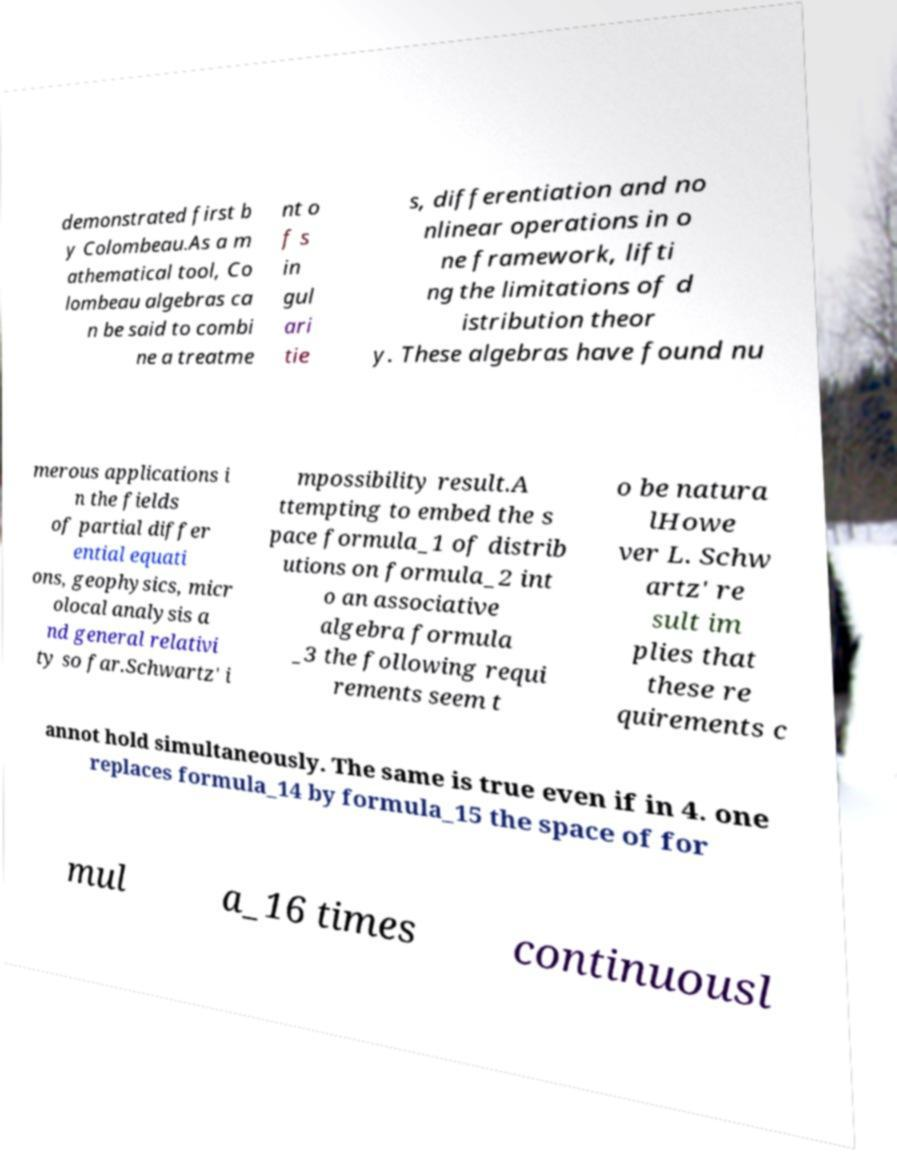There's text embedded in this image that I need extracted. Can you transcribe it verbatim? demonstrated first b y Colombeau.As a m athematical tool, Co lombeau algebras ca n be said to combi ne a treatme nt o f s in gul ari tie s, differentiation and no nlinear operations in o ne framework, lifti ng the limitations of d istribution theor y. These algebras have found nu merous applications i n the fields of partial differ ential equati ons, geophysics, micr olocal analysis a nd general relativi ty so far.Schwartz' i mpossibility result.A ttempting to embed the s pace formula_1 of distrib utions on formula_2 int o an associative algebra formula _3 the following requi rements seem t o be natura lHowe ver L. Schw artz' re sult im plies that these re quirements c annot hold simultaneously. The same is true even if in 4. one replaces formula_14 by formula_15 the space of for mul a_16 times continuousl 